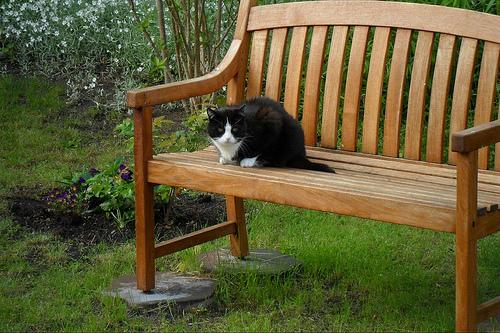Identify the color of the flowers next to the bench. The flowers next to the bench are purple and orange. What is the animal in the image and on what is it seated? There is a domestic house cat sitting on a wooden garden bench. Comment on the construction of the garden bench. The garden bench has a curved top, slatted back, and is hand-made from light brown painted wood. How do recent weather conditions seem to have affected the garden? The garden appears to be wet, possibly from recent rain. What material is the garden bench made of? The garden bench is made out of wood. Provide a short description of the cat's facial features. The cat has a black and white face, yellow eyes, and a pink nose. Mention the colors of the cat in the image. The cat is black and white. What kind of surface is the bench placed on? The bench is placed on dark grey stones. What does the lawn of green grass signify? The lawn of green grass signifies a healthy well-maintained garden. What mood do the freshly planted purple flowers evoke? The freshly planted purple flowers evoke a sense of freshness and beauty in the garden. What are the surroundings of the bench in the image? The bench is surrounded by a healthy lawn, purple flowers, and a row of bushy white flowers. Comment on the quality and sharpness of the image. The image is sharp and crisp, with good contrast and vivid colors. Read the text written on any object in the image. There is no text on any object in the image. Do the bushes have pink flowers instead of white ones? No, it's not mentioned in the image. Which color are the cat's eyes? The cat's eyes are yellow. What is the color of the cat's tail? The cat's tail is black. Is the bench sitting on stones or a cement pad? The bench is sitting on stones. Which type of flowers are planted next to the bench? Purple lavender flowers Evaluate the quality of the image. The image is of good quality with clear details and appropriate brightness. What is the overall sentiment conveyed by the image? The sentiment is positive and serene, as it depicts a peaceful garden scene. Does the cat have blue eyes instead of yellow ones? The cat in the image is described as having yellow eyes, not blue. List the colors and type of flowers in the image. Purple lavender flowers and bushy white flowers. Does the image convey a sense of tranquility or chaos? The image conveys a sense of tranquility. How would you describe the material and structure of the bench? The bench is hand made out of wood, painted light brown, with a slatted back and curved top. Describe the bench's appearance and location. The bench is a light brown, curved top wooden garden bench, sitting on stones and surrounded by flowers and grass. Is the bench made out of metal instead of wood? The bench is described as being wooden, not made of metal. Are the stones beneath the bench light grey instead of dark grey? The stones supporting the bench are mentioned to be dark grey, not light grey. Identify any anomalies in the image. There are no apparent anomalies in the image. Which objects in the image have a mentioned height and width values? All objects in the image have mentioned height and width values. Describe the cat's appearance and location. The cat is black and white with yellow eyes, sitting on a wooden bench. How is the cat interacting with the bench? The cat is sitting on the bench. What animal is sitting on the bench in the picture? A black and white domestic house cat Which object is described as "stump cuttings supporting bench legs"? The wooden pieces under the bench. 